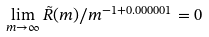Convert formula to latex. <formula><loc_0><loc_0><loc_500><loc_500>\lim _ { m \to \infty } \tilde { R } ( m ) / m ^ { - 1 + 0 . 0 0 0 0 0 1 } = 0</formula> 